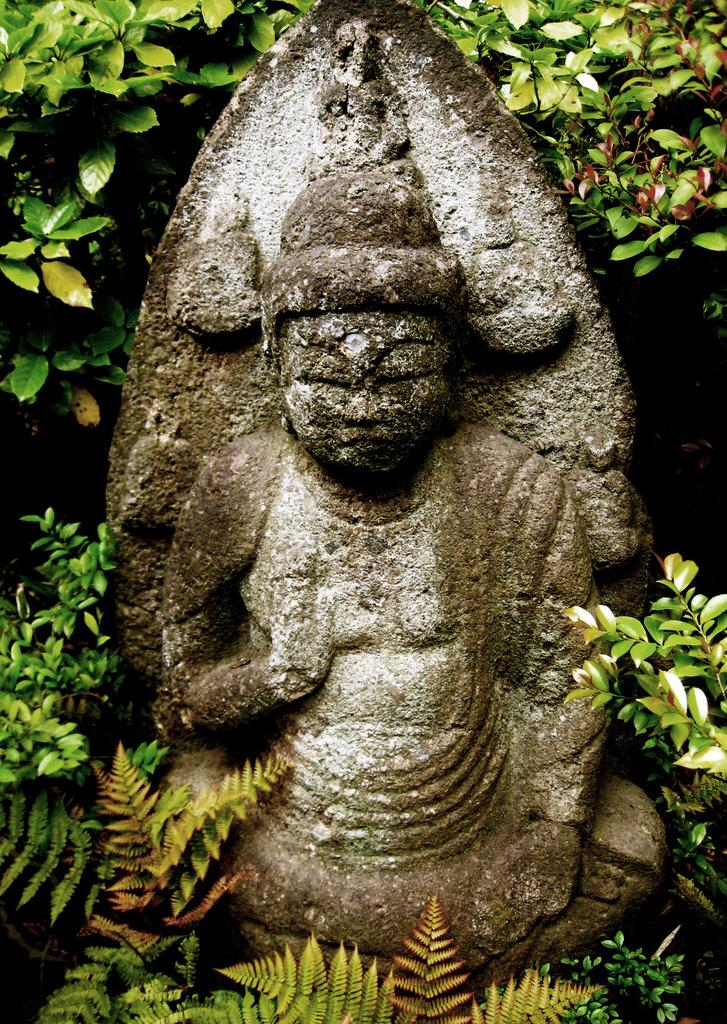What is the main subject in the center of the image? There is a statue in the center of the image. What can be seen in the background of the image? There are plants in the background of the image. Where is the hydrant located in the image? There is no hydrant present in the image. What type of jar is being held by the statue in the image? There is no jar being held by the statue in the image. 